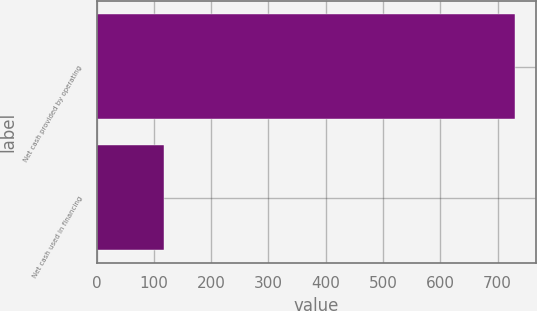<chart> <loc_0><loc_0><loc_500><loc_500><bar_chart><fcel>Net cash provided by operating<fcel>Net cash used in financing<nl><fcel>731<fcel>117<nl></chart> 